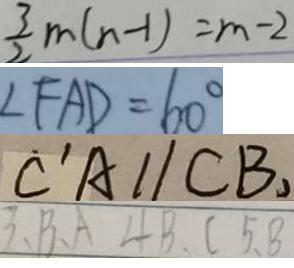Convert formula to latex. <formula><loc_0><loc_0><loc_500><loc_500>\frac { 3 } { 2 } m ( n - 1 ) = m - 2 
 \angle F A D = 6 0 ^ { \circ } 
 \dot { C } ^ { \prime } A / / C B , 
 3 、 B 、 A 4 B 、 C 5 、 8</formula> 